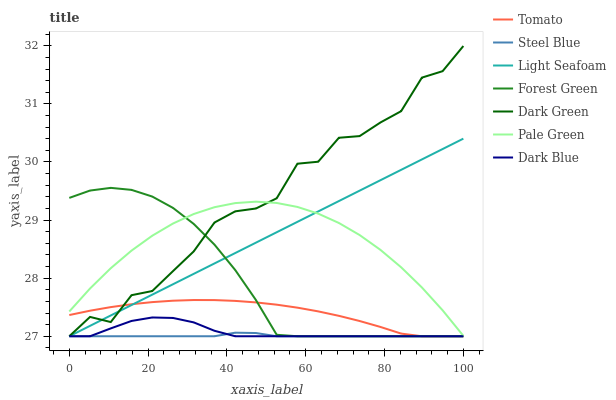Does Steel Blue have the minimum area under the curve?
Answer yes or no. Yes. Does Dark Green have the maximum area under the curve?
Answer yes or no. Yes. Does Dark Blue have the minimum area under the curve?
Answer yes or no. No. Does Dark Blue have the maximum area under the curve?
Answer yes or no. No. Is Light Seafoam the smoothest?
Answer yes or no. Yes. Is Dark Green the roughest?
Answer yes or no. Yes. Is Steel Blue the smoothest?
Answer yes or no. No. Is Steel Blue the roughest?
Answer yes or no. No. Does Tomato have the lowest value?
Answer yes or no. Yes. Does Pale Green have the lowest value?
Answer yes or no. No. Does Dark Green have the highest value?
Answer yes or no. Yes. Does Dark Blue have the highest value?
Answer yes or no. No. Is Steel Blue less than Pale Green?
Answer yes or no. Yes. Is Pale Green greater than Tomato?
Answer yes or no. Yes. Does Steel Blue intersect Forest Green?
Answer yes or no. Yes. Is Steel Blue less than Forest Green?
Answer yes or no. No. Is Steel Blue greater than Forest Green?
Answer yes or no. No. Does Steel Blue intersect Pale Green?
Answer yes or no. No. 